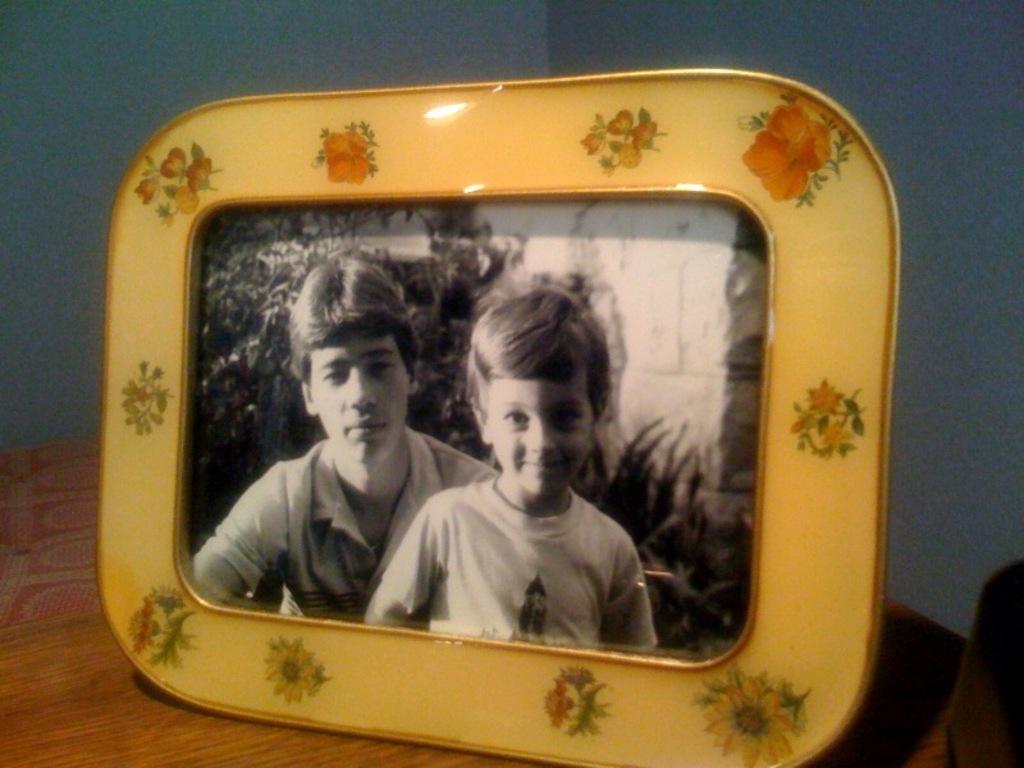Could you give a brief overview of what you see in this image? In the front of the image there is a table, on the table there is a photo frame. In a photo frame I can see two people and plants. In the background of the image there is a wall.   